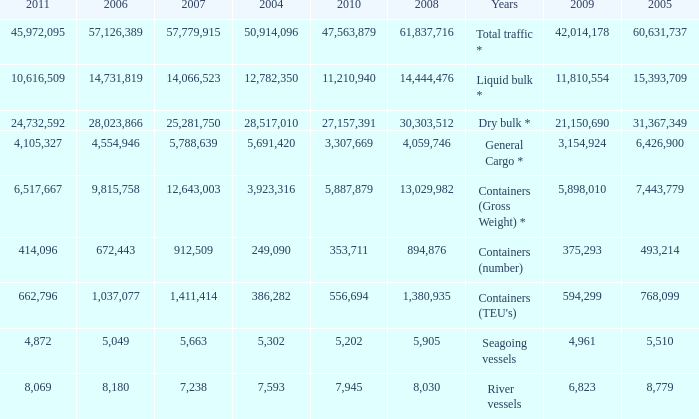What is the highest value in 2011 with less than 5,049 in 2006 and less than 1,380,935 in 2008? None. 